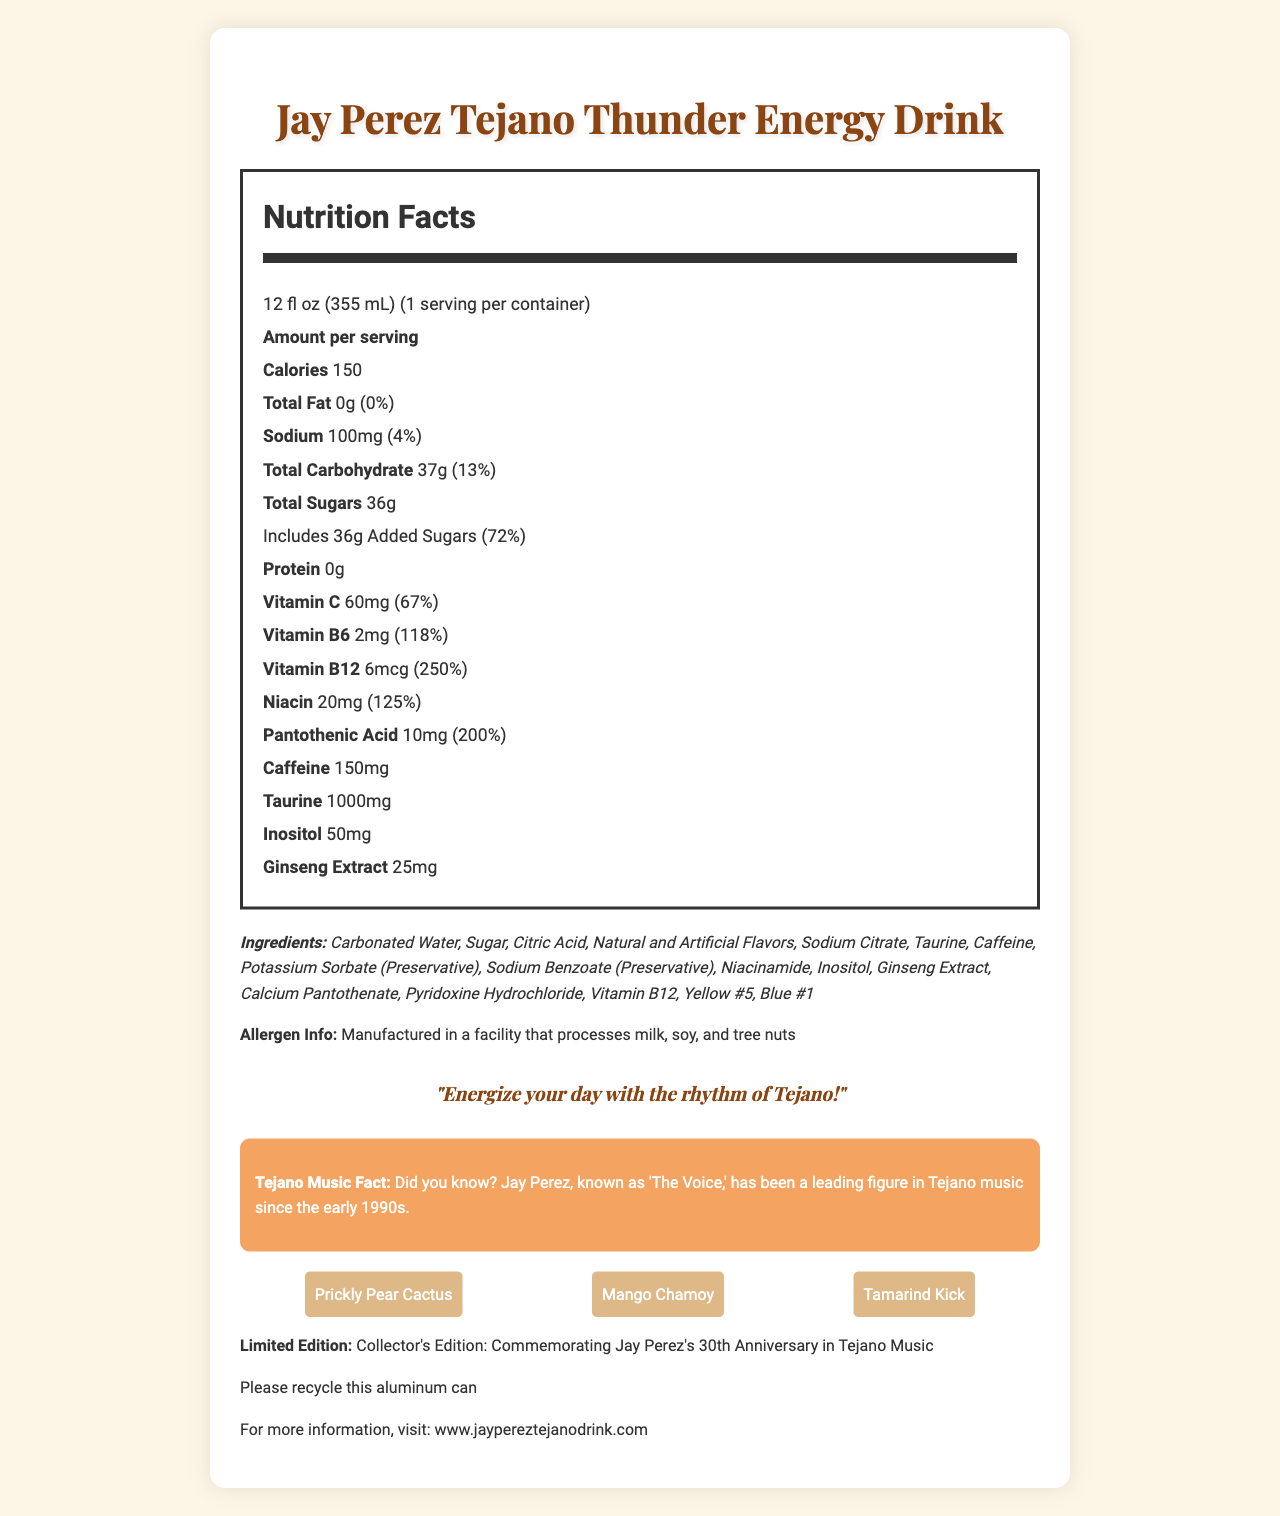what is the serving size of the Jay Perez Tejano Thunder Energy Drink? The serving size is clearly stated as "12 fl oz (355 mL)" at the top of the Nutrition Facts label.
Answer: 12 fl oz (355 mL) how many calories are in a serving of the Jay Perez Tejano Thunder Energy Drink? The document specifies the number of calories per serving as 150.
Answer: 150 what is the total amount of sugars in the drink? The Nutrition Facts label states that the total sugars are 36g per serving.
Answer: 36g what percentage of the daily value for Vitamin B12 does the drink provide? The document mentions that the drink provides 250% of the daily value for Vitamin B12.
Answer: 250% how much caffeine is in a serving of the energy drink? The label indicates that there are 150mg of caffeine in each serving.
Answer: 150mg which of the following vitamins or supplements has the highest daily value percentage? A. Vitamin C B. Vitamin B6 C. Vitamin B12 D. Niacin The daily value percentage for Vitamin B12 is the highest at 250%, compared to Vitamin C (67%), Vitamin B6 (118%), and Niacin (125%).
Answer: C. Vitamin B12 how much sodium does the drink contain as a percentage of the daily value? A. 2% B. 3% C. 4% D. 5% The document shows that the sodium content is 100mg, which is 4% of the daily recommended value.
Answer: C. 4% is this drink suitable for someone who is allergic to tree nuts? The allergen information states that it is manufactured in a facility that processes milk, soy, and tree nuts.
Answer: No describe the main idea of the document. The document provides comprehensive information about the Jay Perez Tejano Thunder Energy Drink, including its nutritional content, ingredients, special features, and background details related to Jay Perez and Tejano music.
Answer: The document details the Nutrition Facts, ingredients, allergen information, and special features of the limited edition 'Jay Perez Tejano Thunder Energy Drink,' which is themed around Jay Perez and incorporates Tejano-inspired flavors. can we determine the price of the Jay Perez Tejano Thunder Energy Drink from this document? The document does not provide any information regarding the price of the Jay Perez Tejano Thunder Energy Drink.
Answer: Cannot be determined 